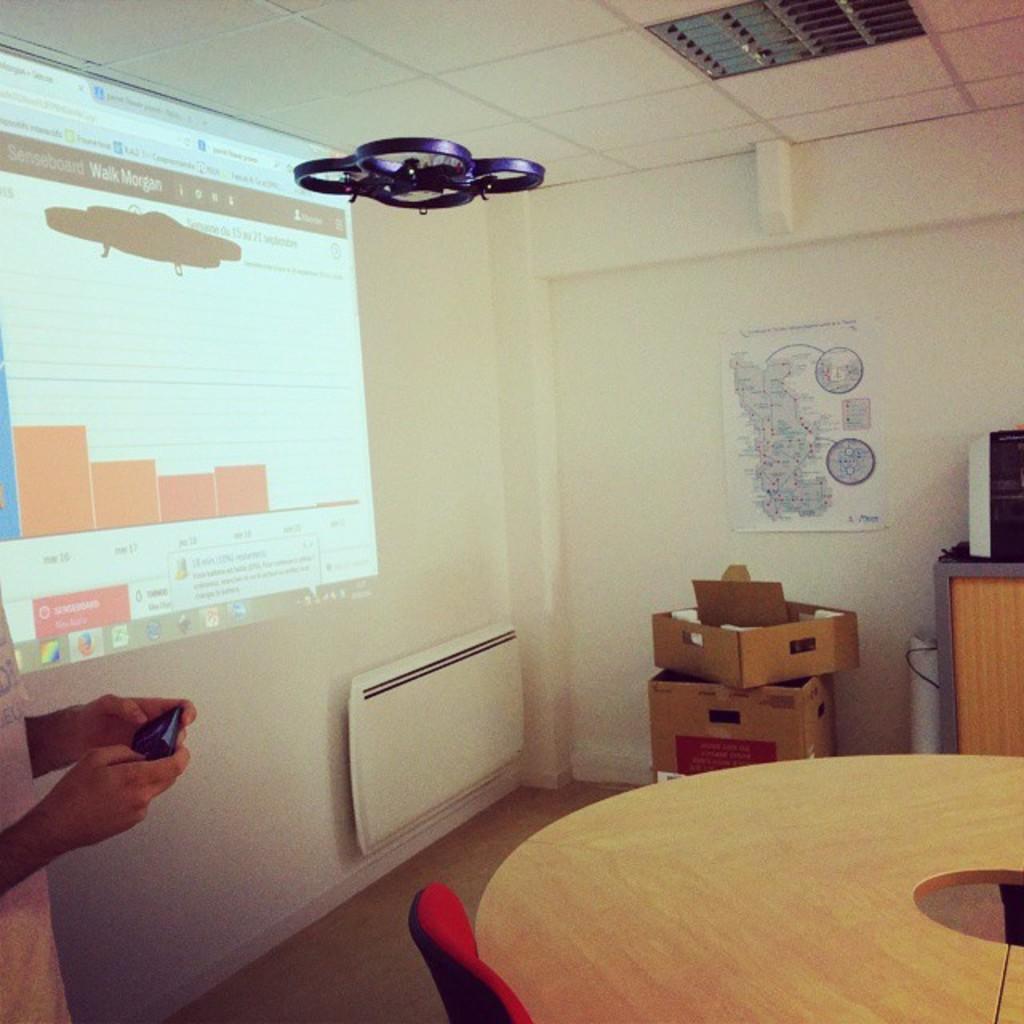Describe this image in one or two sentences. This picture shows an projector screen on the wall and a table and a chair 